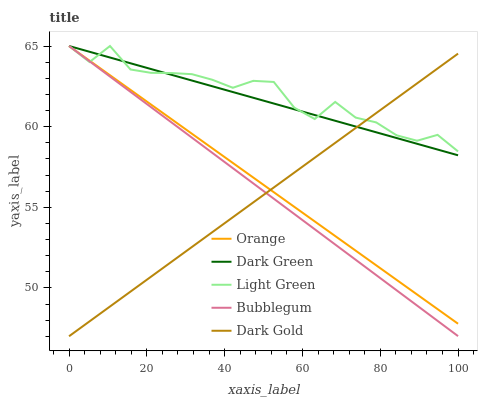Does Dark Gold have the minimum area under the curve?
Answer yes or no. Yes. Does Light Green have the maximum area under the curve?
Answer yes or no. Yes. Does Bubblegum have the minimum area under the curve?
Answer yes or no. No. Does Bubblegum have the maximum area under the curve?
Answer yes or no. No. Is Orange the smoothest?
Answer yes or no. Yes. Is Light Green the roughest?
Answer yes or no. Yes. Is Dark Gold the smoothest?
Answer yes or no. No. Is Dark Gold the roughest?
Answer yes or no. No. Does Dark Gold have the lowest value?
Answer yes or no. Yes. Does Bubblegum have the lowest value?
Answer yes or no. No. Does Dark Green have the highest value?
Answer yes or no. Yes. Does Dark Gold have the highest value?
Answer yes or no. No. Does Orange intersect Bubblegum?
Answer yes or no. Yes. Is Orange less than Bubblegum?
Answer yes or no. No. Is Orange greater than Bubblegum?
Answer yes or no. No. 